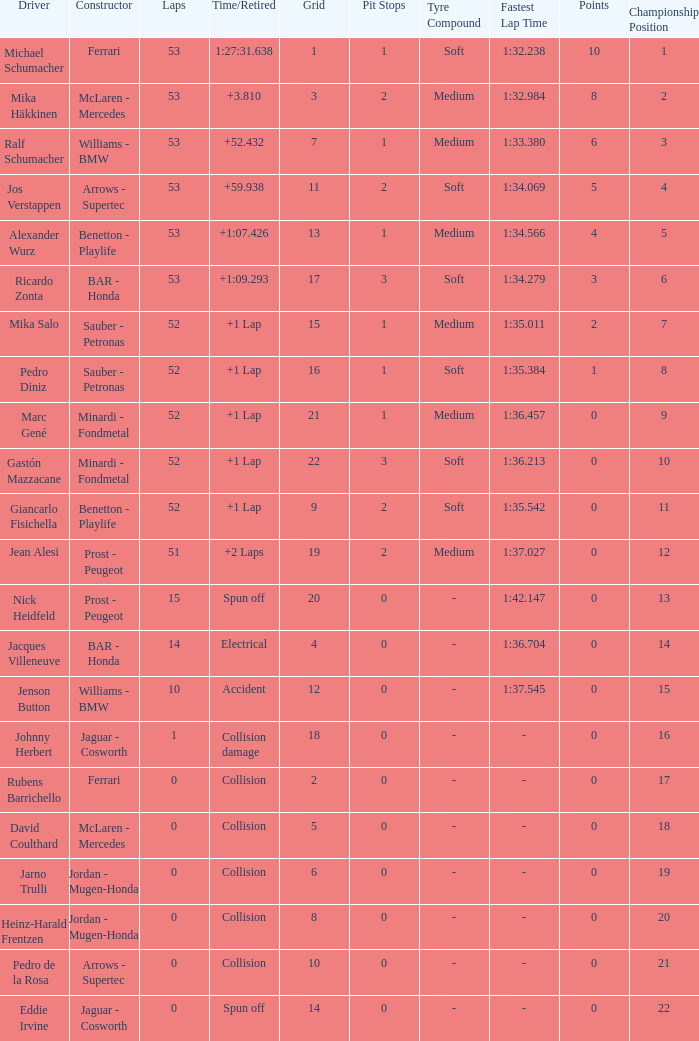What is the name of the driver with a grid less than 14, laps smaller than 53 and a Time/Retired of collision, and a Constructor of ferrari? Rubens Barrichello. I'm looking to parse the entire table for insights. Could you assist me with that? {'header': ['Driver', 'Constructor', 'Laps', 'Time/Retired', 'Grid', 'Pit Stops', 'Tyre Compound', 'Fastest Lap Time', 'Points', 'Championship Position'], 'rows': [['Michael Schumacher', 'Ferrari', '53', '1:27:31.638', '1', '1', 'Soft', '1:32.238', '10', '1'], ['Mika Häkkinen', 'McLaren - Mercedes', '53', '+3.810', '3', '2', 'Medium', '1:32.984', '8', '2'], ['Ralf Schumacher', 'Williams - BMW', '53', '+52.432', '7', '1', 'Medium', '1:33.380', '6', '3'], ['Jos Verstappen', 'Arrows - Supertec', '53', '+59.938', '11', '2', 'Soft', '1:34.069', '5', '4'], ['Alexander Wurz', 'Benetton - Playlife', '53', '+1:07.426', '13', '1', 'Medium', '1:34.566', '4', '5'], ['Ricardo Zonta', 'BAR - Honda', '53', '+1:09.293', '17', '3', 'Soft', '1:34.279', '3', '6'], ['Mika Salo', 'Sauber - Petronas', '52', '+1 Lap', '15', '1', 'Medium', '1:35.011', '2', '7'], ['Pedro Diniz', 'Sauber - Petronas', '52', '+1 Lap', '16', '1', 'Soft', '1:35.384', '1', '8'], ['Marc Gené', 'Minardi - Fondmetal', '52', '+1 Lap', '21', '1', 'Medium', '1:36.457', '0', '9'], ['Gastón Mazzacane', 'Minardi - Fondmetal', '52', '+1 Lap', '22', '3', 'Soft', '1:36.213', '0', '10'], ['Giancarlo Fisichella', 'Benetton - Playlife', '52', '+1 Lap', '9', '2', 'Soft', '1:35.542', '0', '11'], ['Jean Alesi', 'Prost - Peugeot', '51', '+2 Laps', '19', '2', 'Medium', '1:37.027', '0', '12'], ['Nick Heidfeld', 'Prost - Peugeot', '15', 'Spun off', '20', '0', '-', '1:42.147', '0', '13'], ['Jacques Villeneuve', 'BAR - Honda', '14', 'Electrical', '4', '0', '-', '1:36.704', '0', '14'], ['Jenson Button', 'Williams - BMW', '10', 'Accident', '12', '0', '-', '1:37.545', '0', '15'], ['Johnny Herbert', 'Jaguar - Cosworth', '1', 'Collision damage', '18', '0', '-', '-', '0', '16'], ['Rubens Barrichello', 'Ferrari', '0', 'Collision', '2', '0', '-', '-', '0', '17'], ['David Coulthard', 'McLaren - Mercedes', '0', 'Collision', '5', '0', '-', '-', '0', '18'], ['Jarno Trulli', 'Jordan - Mugen-Honda', '0', 'Collision', '6', '0', '-', '-', '0', '19'], ['Heinz-Harald Frentzen', 'Jordan - Mugen-Honda', '0', 'Collision', '8', '0', '-', '-', '0', '20'], ['Pedro de la Rosa', 'Arrows - Supertec', '0', 'Collision', '10', '0', '-', '-', '0', '21'], ['Eddie Irvine', 'Jaguar - Cosworth', '0', 'Spun off', '14', '0', '-', '-', '0', '22']]} 